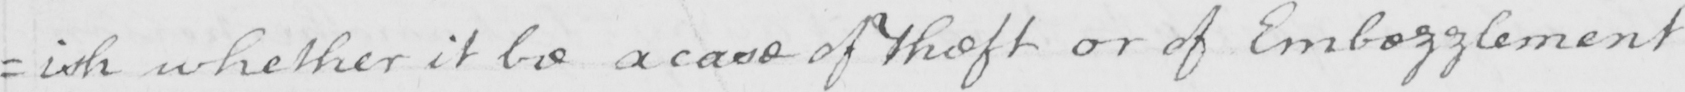Can you tell me what this handwritten text says? =ish whether it be a case of theft or of Embezzlement 